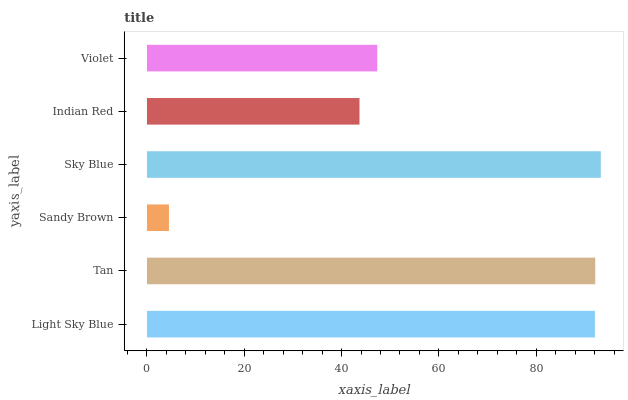Is Sandy Brown the minimum?
Answer yes or no. Yes. Is Sky Blue the maximum?
Answer yes or no. Yes. Is Tan the minimum?
Answer yes or no. No. Is Tan the maximum?
Answer yes or no. No. Is Tan greater than Light Sky Blue?
Answer yes or no. Yes. Is Light Sky Blue less than Tan?
Answer yes or no. Yes. Is Light Sky Blue greater than Tan?
Answer yes or no. No. Is Tan less than Light Sky Blue?
Answer yes or no. No. Is Light Sky Blue the high median?
Answer yes or no. Yes. Is Violet the low median?
Answer yes or no. Yes. Is Sky Blue the high median?
Answer yes or no. No. Is Sky Blue the low median?
Answer yes or no. No. 